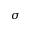<formula> <loc_0><loc_0><loc_500><loc_500>\sigma</formula> 